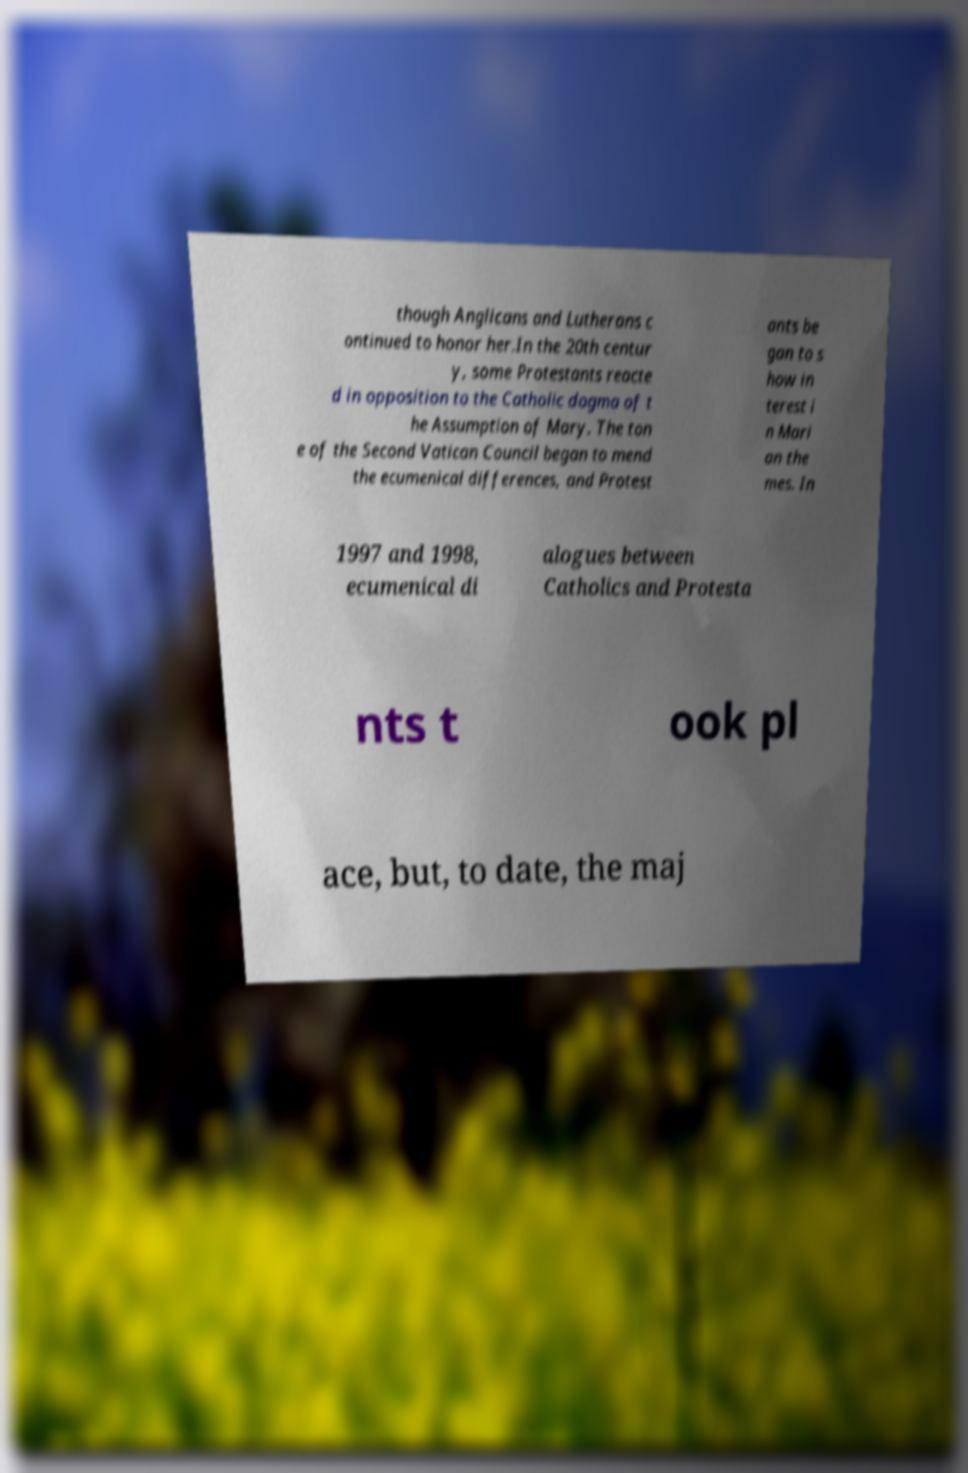For documentation purposes, I need the text within this image transcribed. Could you provide that? though Anglicans and Lutherans c ontinued to honor her.In the 20th centur y, some Protestants reacte d in opposition to the Catholic dogma of t he Assumption of Mary. The ton e of the Second Vatican Council began to mend the ecumenical differences, and Protest ants be gan to s how in terest i n Mari an the mes. In 1997 and 1998, ecumenical di alogues between Catholics and Protesta nts t ook pl ace, but, to date, the maj 